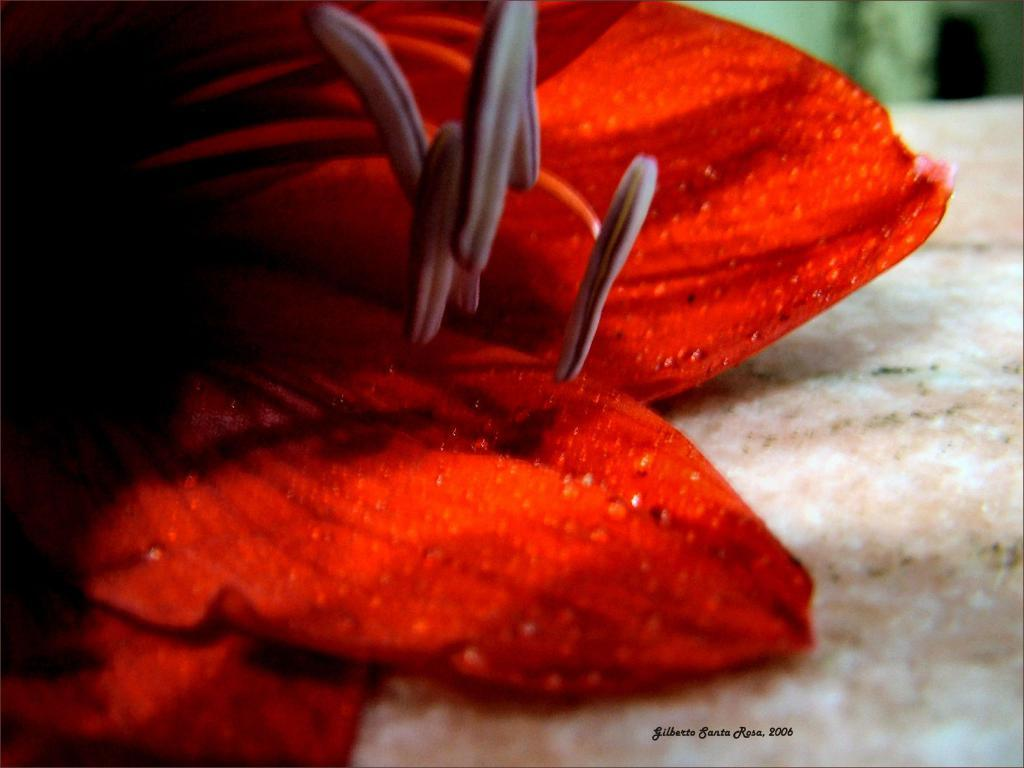What color are the petals in the image? The petals in the image are red. What color is the surface on the right side of the image? The surface on the right side of the image is white. Where is the watermark located in the image? The watermark is on the bottom right of the image. How does the powder affect the moon in the image? There is no powder or moon present in the image. What type of transport can be seen in the image? There is no transport visible in the image. 